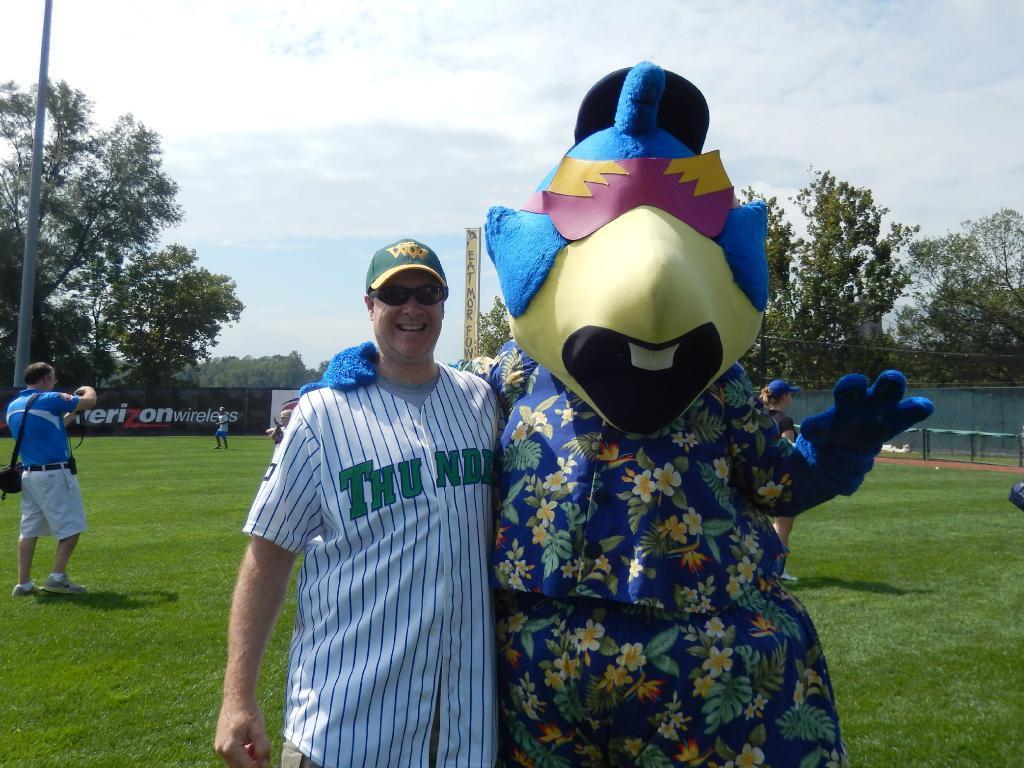Could you give a brief overview of what you see in this image? In this image we can see persons standing on the ground and one is dressed in a costume. In the background we can see sky with clouds, trees, ropes, sportsnet, advertisement and iron bars. 